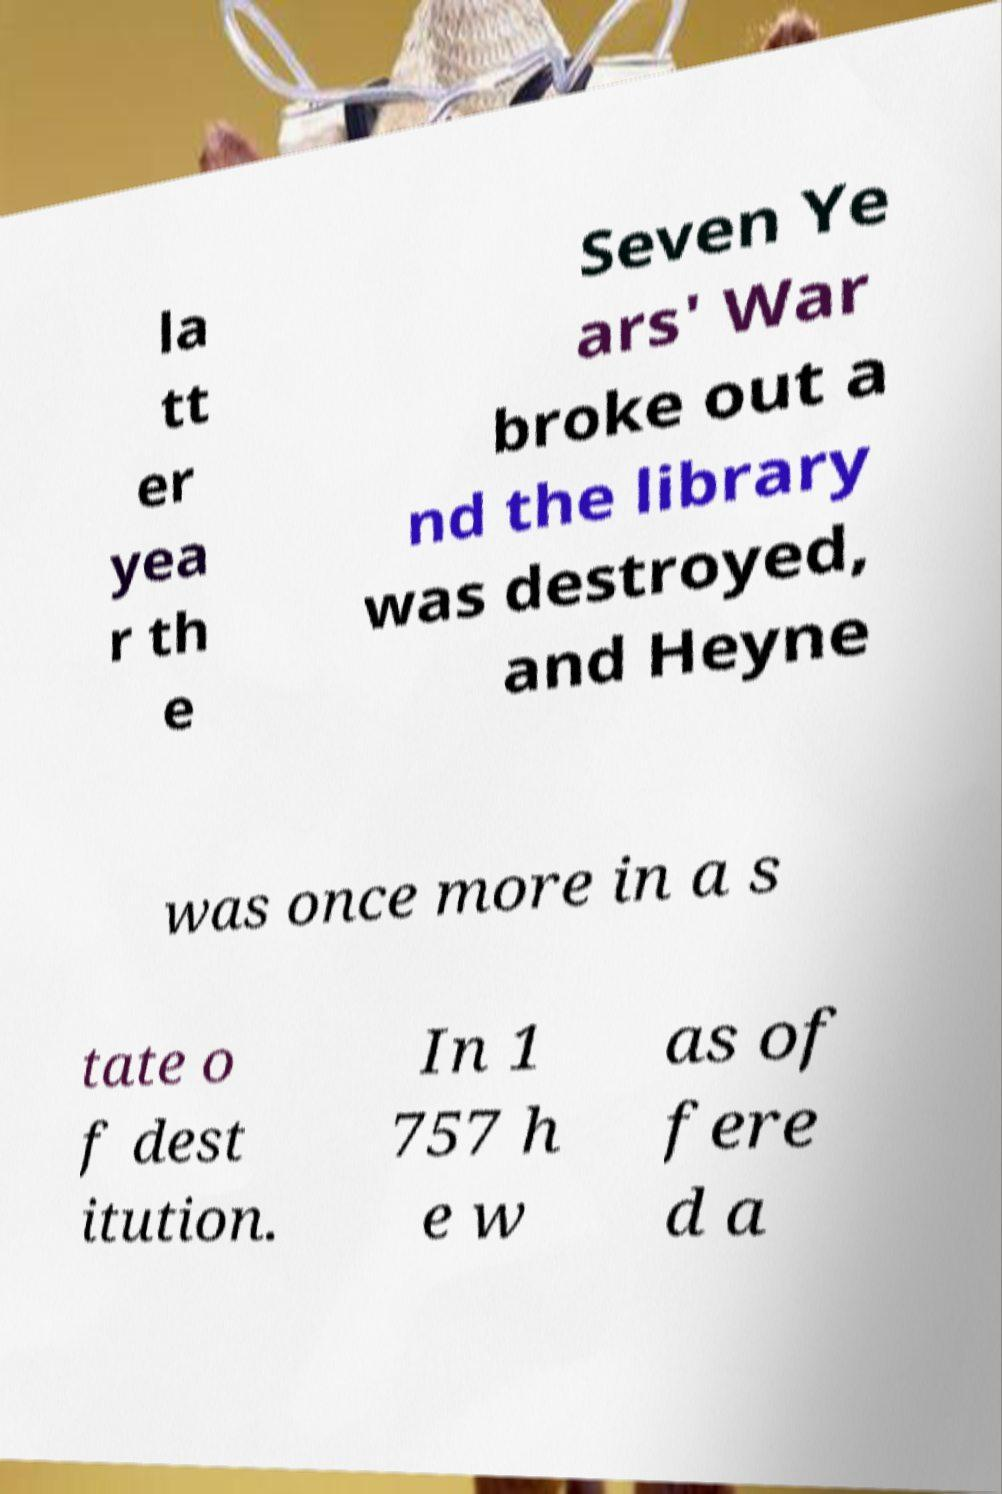Could you extract and type out the text from this image? la tt er yea r th e Seven Ye ars' War broke out a nd the library was destroyed, and Heyne was once more in a s tate o f dest itution. In 1 757 h e w as of fere d a 